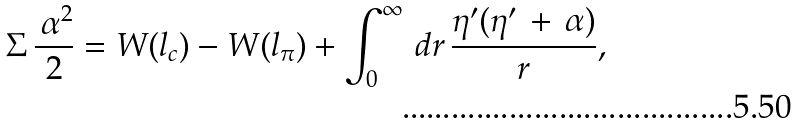Convert formula to latex. <formula><loc_0><loc_0><loc_500><loc_500>\Sigma \, \frac { \, \alpha ^ { 2 } } { 2 } = W ( l _ { c } ) - W ( l _ { \pi } ) + \int _ { 0 } ^ { \infty } \, d r \, \frac { \eta ^ { \prime } ( \eta ^ { \prime } \, + \, \alpha ) } { r } ,</formula> 